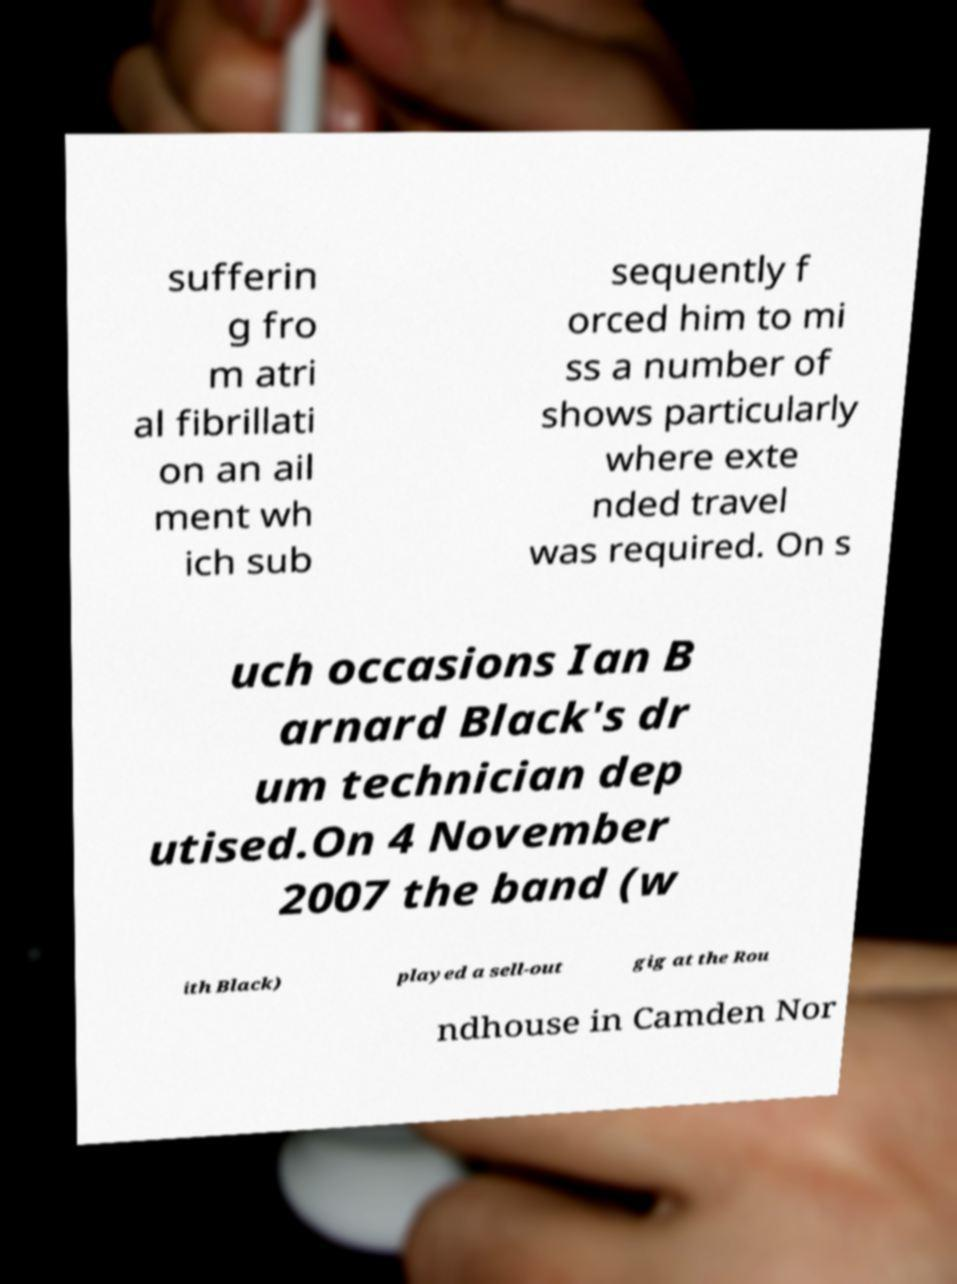Please read and relay the text visible in this image. What does it say? sufferin g fro m atri al fibrillati on an ail ment wh ich sub sequently f orced him to mi ss a number of shows particularly where exte nded travel was required. On s uch occasions Ian B arnard Black's dr um technician dep utised.On 4 November 2007 the band (w ith Black) played a sell-out gig at the Rou ndhouse in Camden Nor 